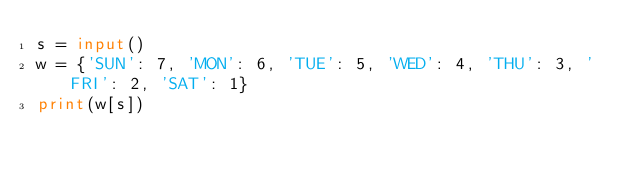<code> <loc_0><loc_0><loc_500><loc_500><_Python_>s = input()
w = {'SUN': 7, 'MON': 6, 'TUE': 5, 'WED': 4, 'THU': 3, 'FRI': 2, 'SAT': 1}
print(w[s])</code> 